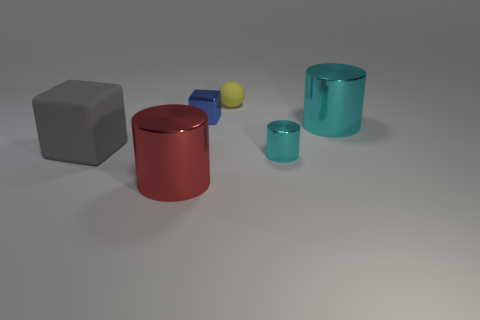There is a matte object that is right of the large red metallic thing; what number of large things are behind it?
Provide a succinct answer. 0. What number of objects are either big matte cubes or tiny blue things?
Make the answer very short. 2. Does the large cyan metallic object have the same shape as the tiny cyan metallic object?
Your answer should be compact. Yes. What is the big gray object made of?
Your answer should be very brief. Rubber. How many things are in front of the tiny blue block and left of the matte ball?
Offer a terse response. 2. Is the blue metallic object the same size as the yellow rubber sphere?
Offer a very short reply. Yes. Do the block that is to the right of the red shiny thing and the tiny cyan thing have the same size?
Your answer should be compact. Yes. What color is the big metal object to the right of the blue thing?
Provide a short and direct response. Cyan. What number of big cylinders are there?
Offer a very short reply. 2. What is the shape of the object that is made of the same material as the yellow sphere?
Provide a short and direct response. Cube. 